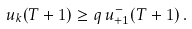<formula> <loc_0><loc_0><loc_500><loc_500>u _ { k } ( T + 1 ) \geq q \, u _ { + 1 } ^ { - } ( T + 1 ) \, .</formula> 